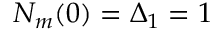<formula> <loc_0><loc_0><loc_500><loc_500>N _ { m } ( 0 ) = \Delta _ { 1 } = 1</formula> 